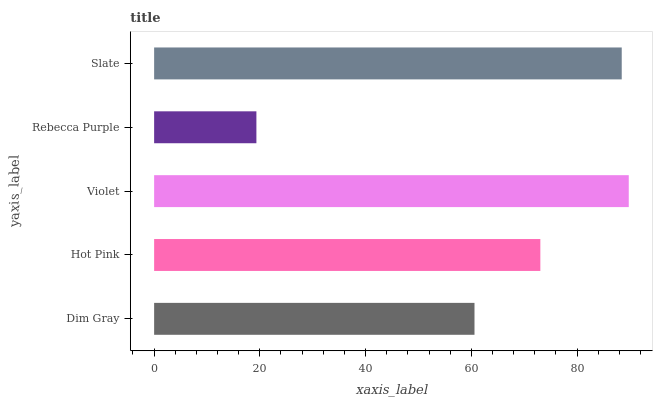Is Rebecca Purple the minimum?
Answer yes or no. Yes. Is Violet the maximum?
Answer yes or no. Yes. Is Hot Pink the minimum?
Answer yes or no. No. Is Hot Pink the maximum?
Answer yes or no. No. Is Hot Pink greater than Dim Gray?
Answer yes or no. Yes. Is Dim Gray less than Hot Pink?
Answer yes or no. Yes. Is Dim Gray greater than Hot Pink?
Answer yes or no. No. Is Hot Pink less than Dim Gray?
Answer yes or no. No. Is Hot Pink the high median?
Answer yes or no. Yes. Is Hot Pink the low median?
Answer yes or no. Yes. Is Violet the high median?
Answer yes or no. No. Is Rebecca Purple the low median?
Answer yes or no. No. 